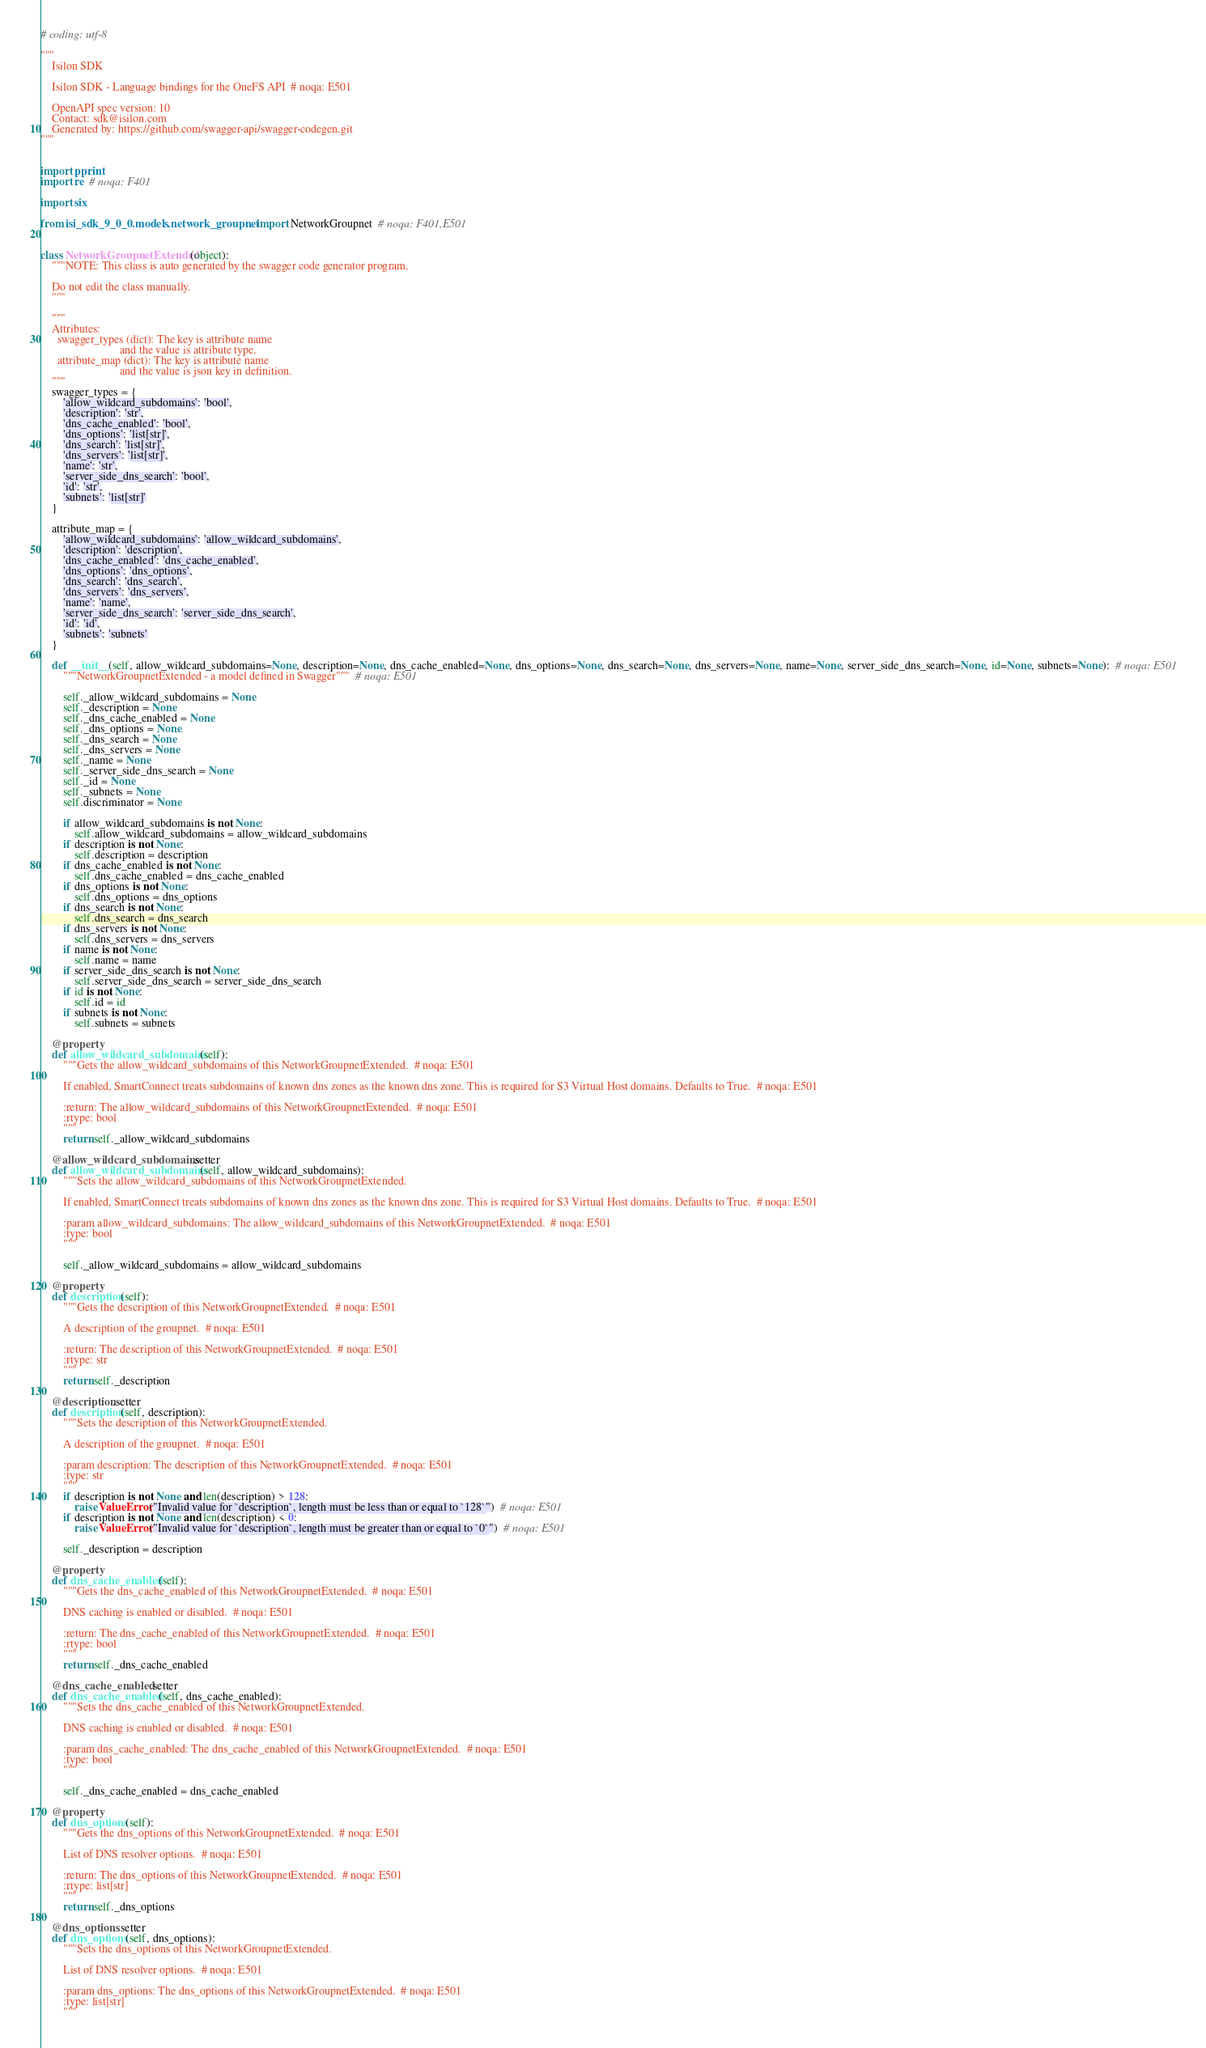<code> <loc_0><loc_0><loc_500><loc_500><_Python_># coding: utf-8

"""
    Isilon SDK

    Isilon SDK - Language bindings for the OneFS API  # noqa: E501

    OpenAPI spec version: 10
    Contact: sdk@isilon.com
    Generated by: https://github.com/swagger-api/swagger-codegen.git
"""


import pprint
import re  # noqa: F401

import six

from isi_sdk_9_0_0.models.network_groupnet import NetworkGroupnet  # noqa: F401,E501


class NetworkGroupnetExtended(object):
    """NOTE: This class is auto generated by the swagger code generator program.

    Do not edit the class manually.
    """

    """
    Attributes:
      swagger_types (dict): The key is attribute name
                            and the value is attribute type.
      attribute_map (dict): The key is attribute name
                            and the value is json key in definition.
    """
    swagger_types = {
        'allow_wildcard_subdomains': 'bool',
        'description': 'str',
        'dns_cache_enabled': 'bool',
        'dns_options': 'list[str]',
        'dns_search': 'list[str]',
        'dns_servers': 'list[str]',
        'name': 'str',
        'server_side_dns_search': 'bool',
        'id': 'str',
        'subnets': 'list[str]'
    }

    attribute_map = {
        'allow_wildcard_subdomains': 'allow_wildcard_subdomains',
        'description': 'description',
        'dns_cache_enabled': 'dns_cache_enabled',
        'dns_options': 'dns_options',
        'dns_search': 'dns_search',
        'dns_servers': 'dns_servers',
        'name': 'name',
        'server_side_dns_search': 'server_side_dns_search',
        'id': 'id',
        'subnets': 'subnets'
    }

    def __init__(self, allow_wildcard_subdomains=None, description=None, dns_cache_enabled=None, dns_options=None, dns_search=None, dns_servers=None, name=None, server_side_dns_search=None, id=None, subnets=None):  # noqa: E501
        """NetworkGroupnetExtended - a model defined in Swagger"""  # noqa: E501

        self._allow_wildcard_subdomains = None
        self._description = None
        self._dns_cache_enabled = None
        self._dns_options = None
        self._dns_search = None
        self._dns_servers = None
        self._name = None
        self._server_side_dns_search = None
        self._id = None
        self._subnets = None
        self.discriminator = None

        if allow_wildcard_subdomains is not None:
            self.allow_wildcard_subdomains = allow_wildcard_subdomains
        if description is not None:
            self.description = description
        if dns_cache_enabled is not None:
            self.dns_cache_enabled = dns_cache_enabled
        if dns_options is not None:
            self.dns_options = dns_options
        if dns_search is not None:
            self.dns_search = dns_search
        if dns_servers is not None:
            self.dns_servers = dns_servers
        if name is not None:
            self.name = name
        if server_side_dns_search is not None:
            self.server_side_dns_search = server_side_dns_search
        if id is not None:
            self.id = id
        if subnets is not None:
            self.subnets = subnets

    @property
    def allow_wildcard_subdomains(self):
        """Gets the allow_wildcard_subdomains of this NetworkGroupnetExtended.  # noqa: E501

        If enabled, SmartConnect treats subdomains of known dns zones as the known dns zone. This is required for S3 Virtual Host domains. Defaults to True.  # noqa: E501

        :return: The allow_wildcard_subdomains of this NetworkGroupnetExtended.  # noqa: E501
        :rtype: bool
        """
        return self._allow_wildcard_subdomains

    @allow_wildcard_subdomains.setter
    def allow_wildcard_subdomains(self, allow_wildcard_subdomains):
        """Sets the allow_wildcard_subdomains of this NetworkGroupnetExtended.

        If enabled, SmartConnect treats subdomains of known dns zones as the known dns zone. This is required for S3 Virtual Host domains. Defaults to True.  # noqa: E501

        :param allow_wildcard_subdomains: The allow_wildcard_subdomains of this NetworkGroupnetExtended.  # noqa: E501
        :type: bool
        """

        self._allow_wildcard_subdomains = allow_wildcard_subdomains

    @property
    def description(self):
        """Gets the description of this NetworkGroupnetExtended.  # noqa: E501

        A description of the groupnet.  # noqa: E501

        :return: The description of this NetworkGroupnetExtended.  # noqa: E501
        :rtype: str
        """
        return self._description

    @description.setter
    def description(self, description):
        """Sets the description of this NetworkGroupnetExtended.

        A description of the groupnet.  # noqa: E501

        :param description: The description of this NetworkGroupnetExtended.  # noqa: E501
        :type: str
        """
        if description is not None and len(description) > 128:
            raise ValueError("Invalid value for `description`, length must be less than or equal to `128`")  # noqa: E501
        if description is not None and len(description) < 0:
            raise ValueError("Invalid value for `description`, length must be greater than or equal to `0`")  # noqa: E501

        self._description = description

    @property
    def dns_cache_enabled(self):
        """Gets the dns_cache_enabled of this NetworkGroupnetExtended.  # noqa: E501

        DNS caching is enabled or disabled.  # noqa: E501

        :return: The dns_cache_enabled of this NetworkGroupnetExtended.  # noqa: E501
        :rtype: bool
        """
        return self._dns_cache_enabled

    @dns_cache_enabled.setter
    def dns_cache_enabled(self, dns_cache_enabled):
        """Sets the dns_cache_enabled of this NetworkGroupnetExtended.

        DNS caching is enabled or disabled.  # noqa: E501

        :param dns_cache_enabled: The dns_cache_enabled of this NetworkGroupnetExtended.  # noqa: E501
        :type: bool
        """

        self._dns_cache_enabled = dns_cache_enabled

    @property
    def dns_options(self):
        """Gets the dns_options of this NetworkGroupnetExtended.  # noqa: E501

        List of DNS resolver options.  # noqa: E501

        :return: The dns_options of this NetworkGroupnetExtended.  # noqa: E501
        :rtype: list[str]
        """
        return self._dns_options

    @dns_options.setter
    def dns_options(self, dns_options):
        """Sets the dns_options of this NetworkGroupnetExtended.

        List of DNS resolver options.  # noqa: E501

        :param dns_options: The dns_options of this NetworkGroupnetExtended.  # noqa: E501
        :type: list[str]
        """</code> 